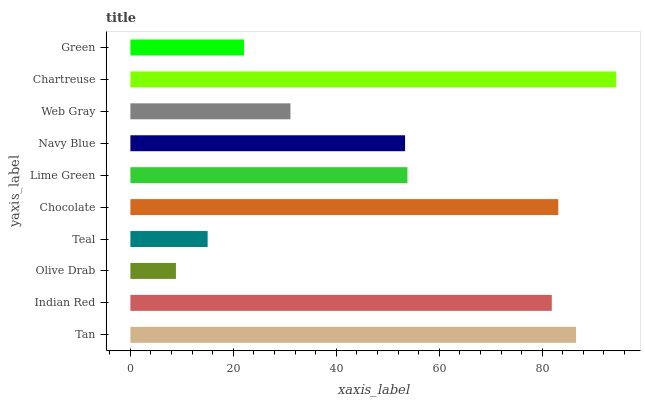Is Olive Drab the minimum?
Answer yes or no. Yes. Is Chartreuse the maximum?
Answer yes or no. Yes. Is Indian Red the minimum?
Answer yes or no. No. Is Indian Red the maximum?
Answer yes or no. No. Is Tan greater than Indian Red?
Answer yes or no. Yes. Is Indian Red less than Tan?
Answer yes or no. Yes. Is Indian Red greater than Tan?
Answer yes or no. No. Is Tan less than Indian Red?
Answer yes or no. No. Is Lime Green the high median?
Answer yes or no. Yes. Is Navy Blue the low median?
Answer yes or no. Yes. Is Web Gray the high median?
Answer yes or no. No. Is Teal the low median?
Answer yes or no. No. 